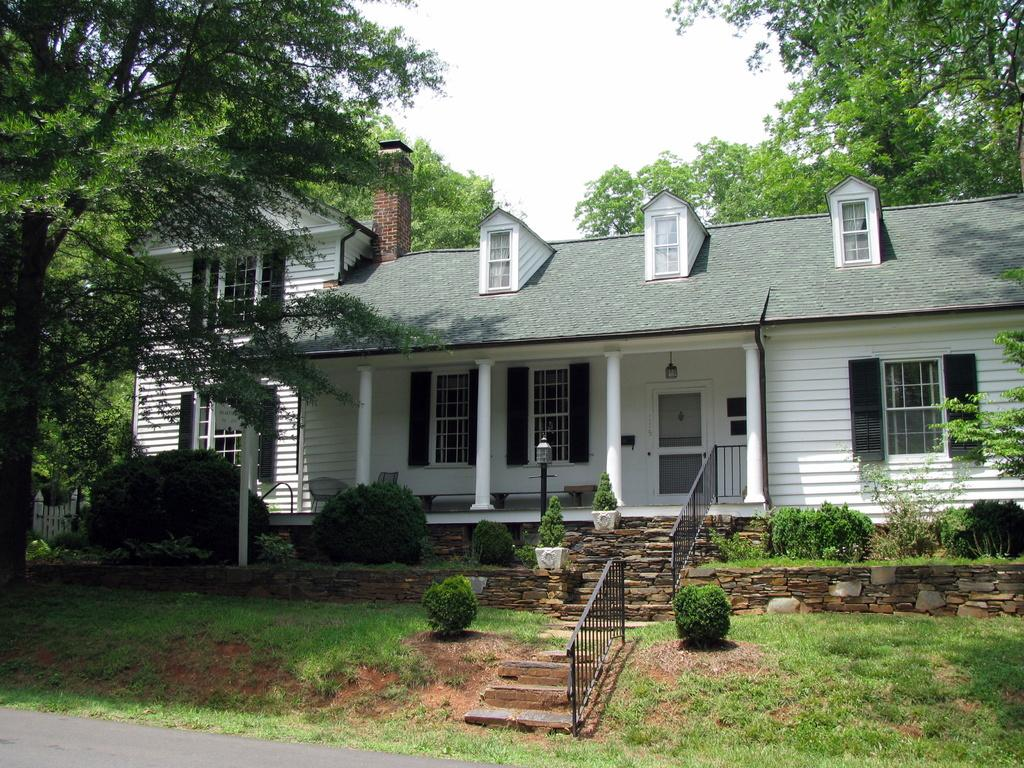What type of structure is visible in the image? There is a house in the image. What is the primary pathway in the image? There is a road in the image. What can be seen above the house and road? The sky is visible in the image. What type of terrain is present in the image? There is grassy land in the image. What type of vegetation is present in the image? There are many trees and plants in the image. Are there any architectural features related to elevation in the image? Yes, there are staircases in the image. Can you see a squirrel climbing up one of the trees in the image? There is no squirrel present in the image; only trees, plants, and other objects are visible. Is there a cub playing with the plants in the image? There is no cub present in the image; only trees, plants, and other objects are visible. 